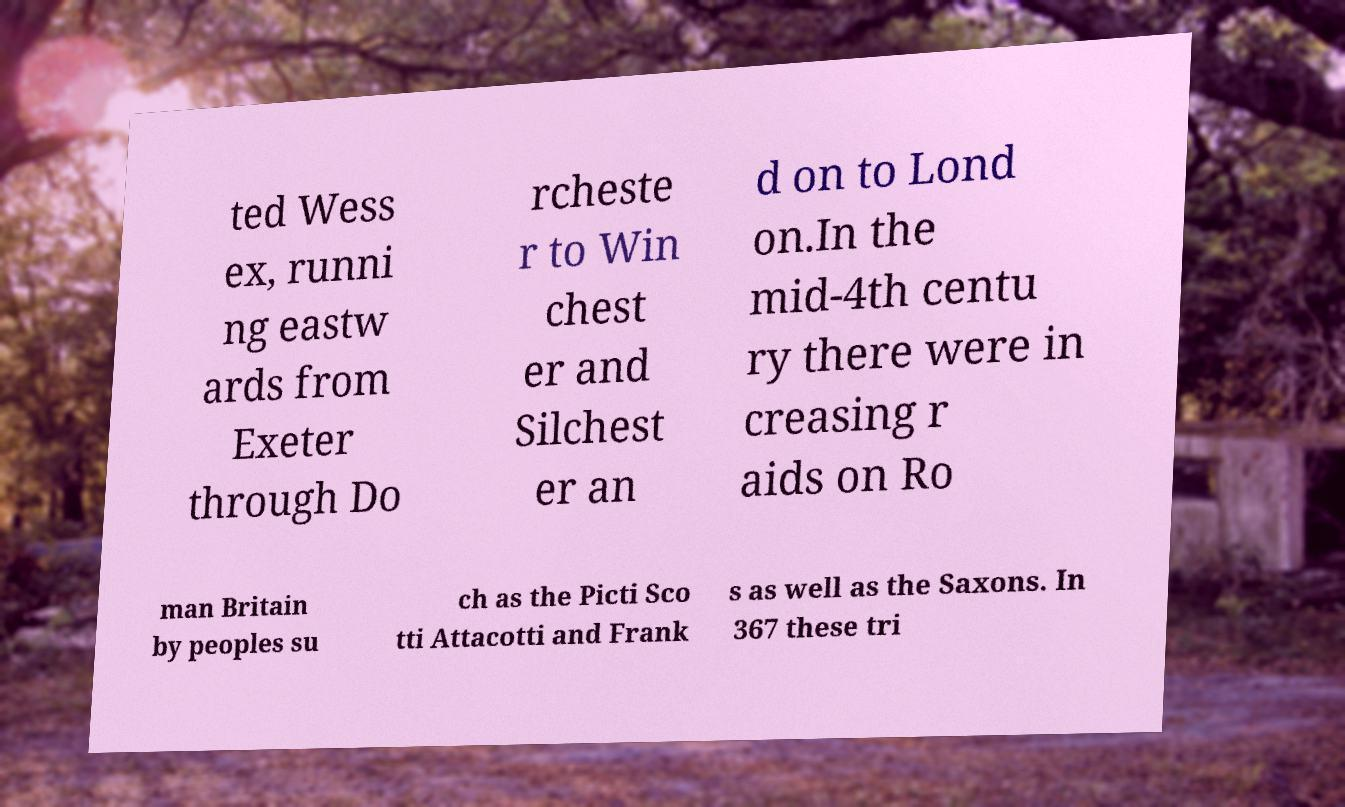Could you extract and type out the text from this image? ted Wess ex, runni ng eastw ards from Exeter through Do rcheste r to Win chest er and Silchest er an d on to Lond on.In the mid-4th centu ry there were in creasing r aids on Ro man Britain by peoples su ch as the Picti Sco tti Attacotti and Frank s as well as the Saxons. In 367 these tri 